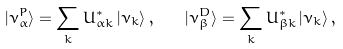Convert formula to latex. <formula><loc_0><loc_0><loc_500><loc_500>| \nu _ { \alpha } ^ { P } \rangle = \sum _ { k } U _ { \alpha k } ^ { * } \, | \nu _ { k } \rangle \, , \quad | \nu _ { \beta } ^ { D } \rangle = \sum _ { k } U _ { \beta k } ^ { * } \, | \nu _ { k } \rangle \, ,</formula> 